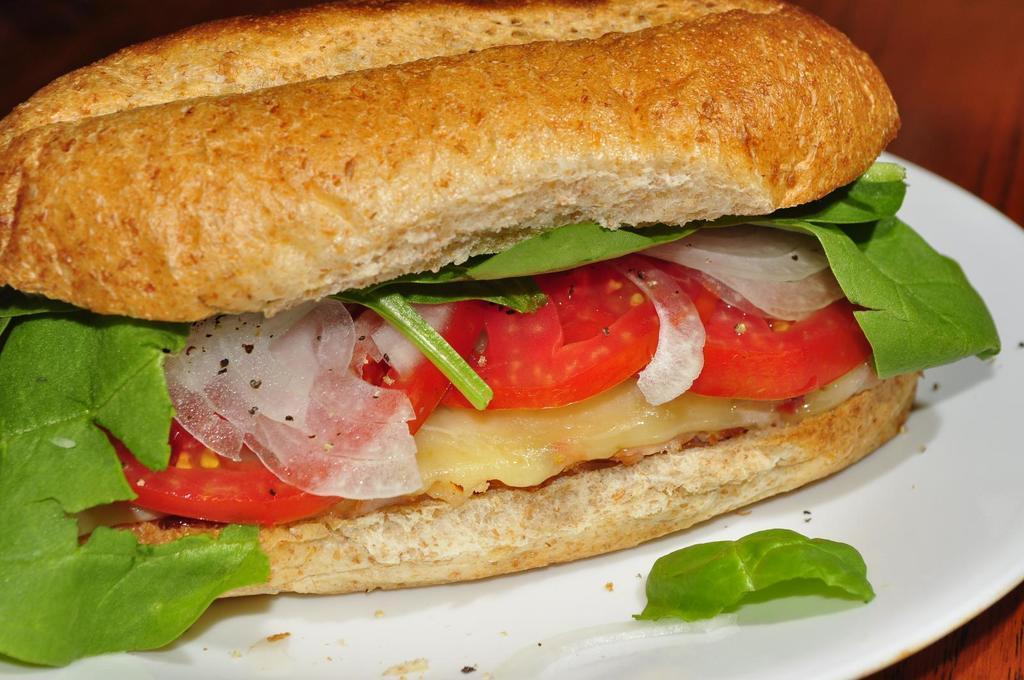Could you give a brief overview of what you see in this image? In this image I can see food which is in brown, red and green color on the plate and the plate is in white color. 